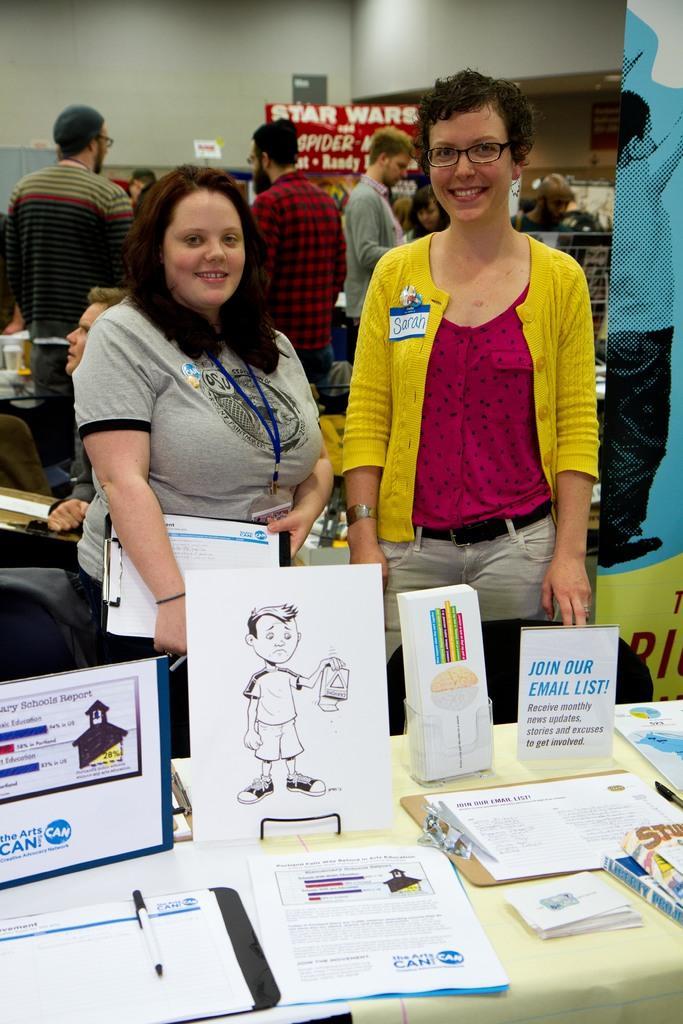In one or two sentences, can you explain what this image depicts? In this picture, we see two women are standing. They are smiling and they might be posing for the photo. The woman on the left side is holding the papers and a pen. In front of them, we see a table on which papers, books, files and white boards are placed. On the right side, we see a board or a banner in blue and yellow color. Behind them, we see a man is sitting on the chair. Beside him, we see the people are standing. In the background, we see a red color board with some text written on it. In the background, we see a wall. 